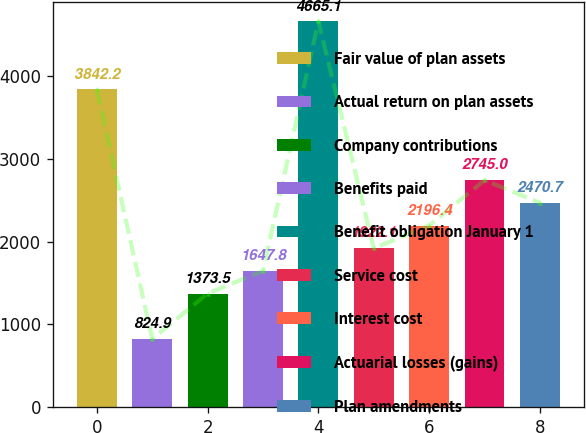<chart> <loc_0><loc_0><loc_500><loc_500><bar_chart><fcel>Fair value of plan assets<fcel>Actual return on plan assets<fcel>Company contributions<fcel>Benefits paid<fcel>Benefit obligation January 1<fcel>Service cost<fcel>Interest cost<fcel>Actuarial losses (gains)<fcel>Plan amendments<nl><fcel>3842.2<fcel>824.9<fcel>1373.5<fcel>1647.8<fcel>4665.1<fcel>1922.1<fcel>2196.4<fcel>2745<fcel>2470.7<nl></chart> 